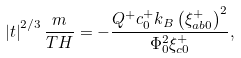<formula> <loc_0><loc_0><loc_500><loc_500>\left | t \right | ^ { 2 / 3 } \frac { m } { T H } = - \frac { Q ^ { + } c _ { 0 } ^ { + } k _ { B } \left ( \xi _ { a b 0 } ^ { + } \right ) ^ { 2 } } { \Phi _ { 0 } ^ { 2 } \xi _ { c 0 } ^ { + } } ,</formula> 